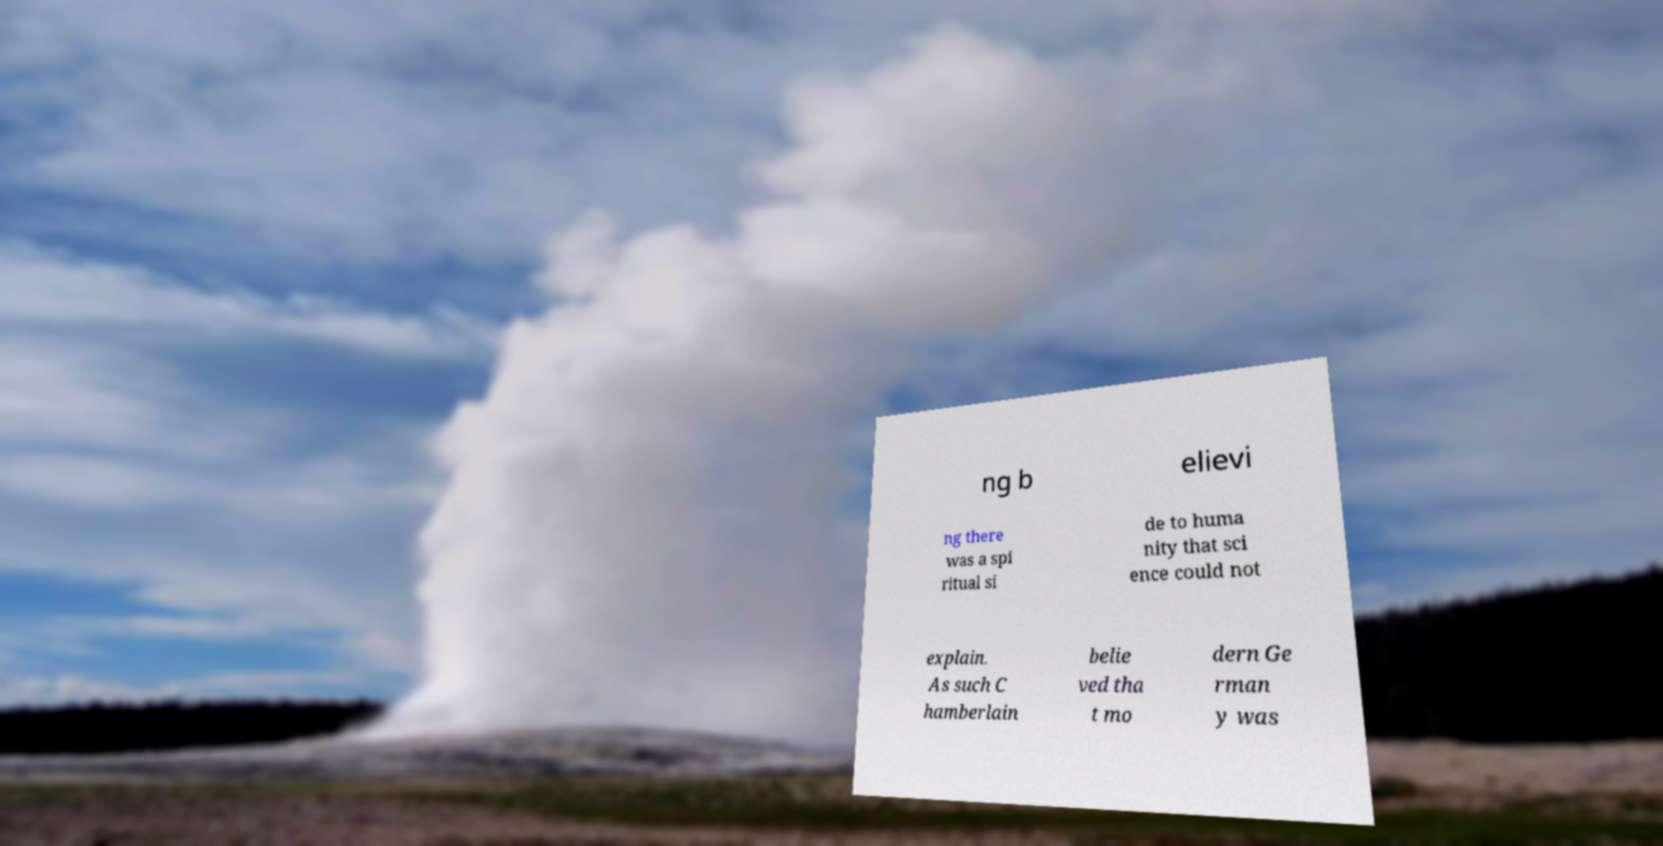Can you read and provide the text displayed in the image?This photo seems to have some interesting text. Can you extract and type it out for me? ng b elievi ng there was a spi ritual si de to huma nity that sci ence could not explain. As such C hamberlain belie ved tha t mo dern Ge rman y was 